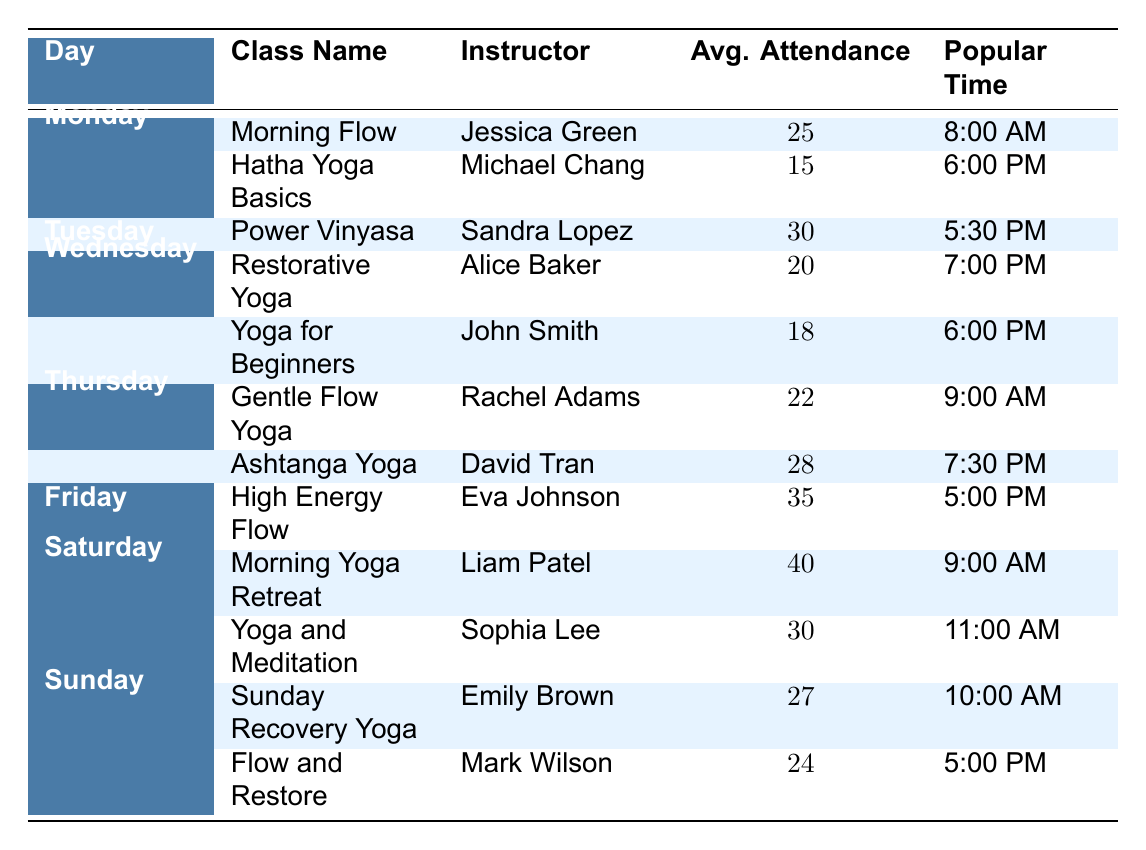What is the average attendance for classes on Saturday? There are two classes on Saturday: Morning Yoga Retreat with 40 attendees and Yoga and Meditation with 30 attendees. To find the average, we sum the attendance values (40 + 30 = 70) and divide by the number of classes (2). Therefore, the average attendance is 70/2 = 35.
Answer: 35 Which class has the highest average attendance? The class with the highest average attendance is High Energy Flow on Friday, with 35 attendees. This can be identified by comparing the average attendance figures for each class listed in the table.
Answer: High Energy Flow Is Power Vinyasa offered during the morning? Power Vinyasa is offered on Tuesday at 5:30 PM. Since this time is in the evening, the answer is no.
Answer: No What is the most popular time for classes on Thursday? There are two classes on Thursday: Gentle Flow Yoga at 9:00 AM and Ashtanga Yoga at 7:30 PM. The most popular time for both classes can be listed as the respective times since both classes have their own popular times.
Answer: 9:00 AM, 7:30 PM What is the total average attendance for all classes on Sunday? The classes on Sunday are Sunday Recovery Yoga with an attendance of 27 and Flow and Restore with an attendance of 24. To find the total average attendance, we add these two values (27 + 24 = 51) and divide by the number of classes (2). Thus, the average attendance for Sunday is 51/2 = 25.5.
Answer: 25.5 On which day does Yoga for Beginners take place? Yoga for Beginners is listed as a Wednesday class. This information can be directly found in the day column associated with the class name.
Answer: Wednesday Is there a class called Hatha Yoga Basics on Thursday? Hatha Yoga Basics is actually scheduled for Monday, not Thursday. This can be verified by checking the scheduled classes for each day in the table.
Answer: No What is the difference in average attendance between the highest and lowest attended class? The highest attended class is Saturday's Morning Yoga Retreat with 40 attendees, while the lowest is Hatha Yoga Basics on Monday with 15 attendees. The difference is calculated by subtracting (40 - 15 = 25). This gives us the difference in average attendance between these two classes.
Answer: 25 